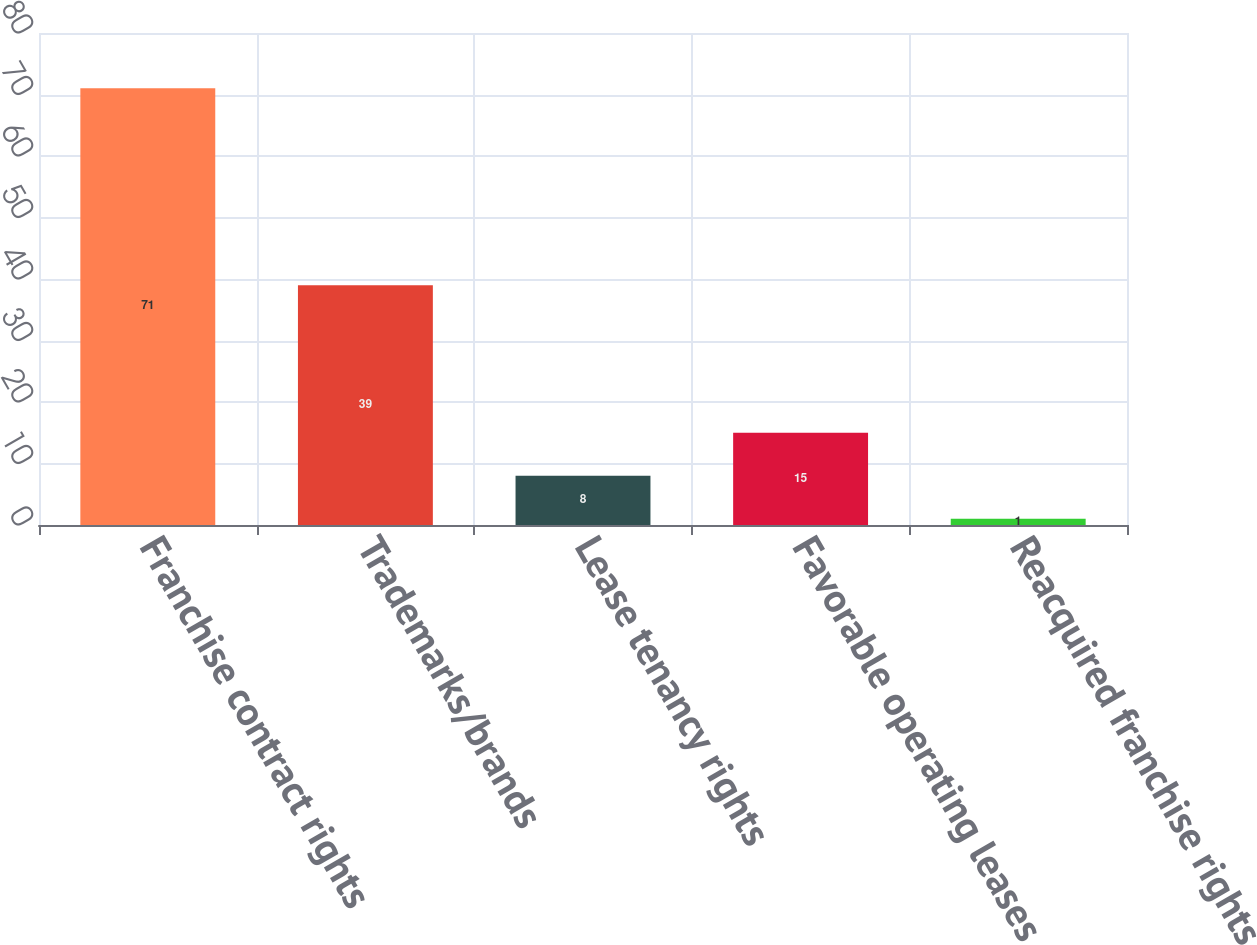Convert chart to OTSL. <chart><loc_0><loc_0><loc_500><loc_500><bar_chart><fcel>Franchise contract rights<fcel>Trademarks/brands<fcel>Lease tenancy rights<fcel>Favorable operating leases<fcel>Reacquired franchise rights<nl><fcel>71<fcel>39<fcel>8<fcel>15<fcel>1<nl></chart> 